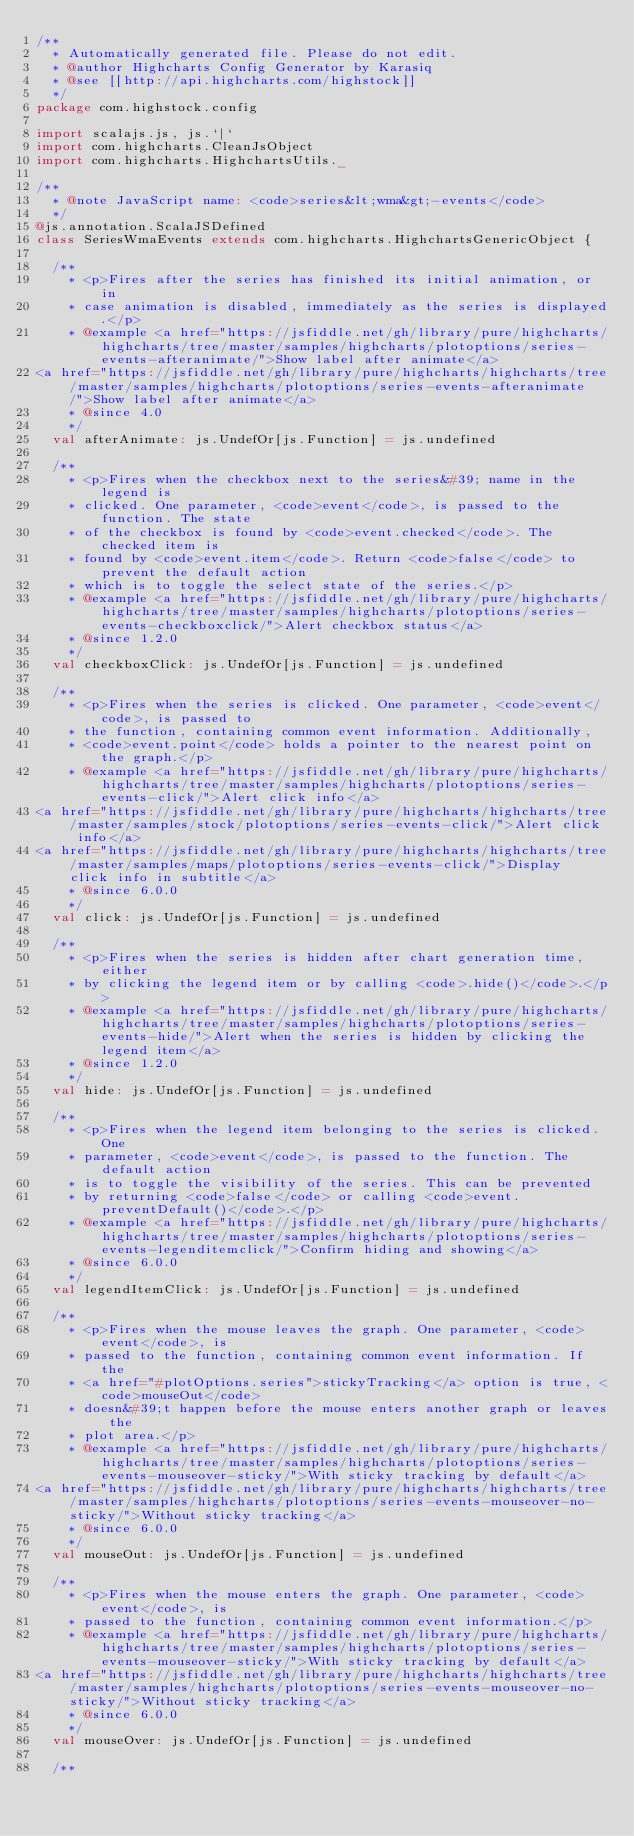<code> <loc_0><loc_0><loc_500><loc_500><_Scala_>/**
  * Automatically generated file. Please do not edit.
  * @author Highcharts Config Generator by Karasiq
  * @see [[http://api.highcharts.com/highstock]]
  */
package com.highstock.config

import scalajs.js, js.`|`
import com.highcharts.CleanJsObject
import com.highcharts.HighchartsUtils._

/**
  * @note JavaScript name: <code>series&lt;wma&gt;-events</code>
  */
@js.annotation.ScalaJSDefined
class SeriesWmaEvents extends com.highcharts.HighchartsGenericObject {

  /**
    * <p>Fires after the series has finished its initial animation, or in
    * case animation is disabled, immediately as the series is displayed.</p>
    * @example <a href="https://jsfiddle.net/gh/library/pure/highcharts/highcharts/tree/master/samples/highcharts/plotoptions/series-events-afteranimate/">Show label after animate</a>
<a href="https://jsfiddle.net/gh/library/pure/highcharts/highcharts/tree/master/samples/highcharts/plotoptions/series-events-afteranimate/">Show label after animate</a>
    * @since 4.0
    */
  val afterAnimate: js.UndefOr[js.Function] = js.undefined

  /**
    * <p>Fires when the checkbox next to the series&#39; name in the legend is
    * clicked. One parameter, <code>event</code>, is passed to the function. The state
    * of the checkbox is found by <code>event.checked</code>. The checked item is
    * found by <code>event.item</code>. Return <code>false</code> to prevent the default action
    * which is to toggle the select state of the series.</p>
    * @example <a href="https://jsfiddle.net/gh/library/pure/highcharts/highcharts/tree/master/samples/highcharts/plotoptions/series-events-checkboxclick/">Alert checkbox status</a>
    * @since 1.2.0
    */
  val checkboxClick: js.UndefOr[js.Function] = js.undefined

  /**
    * <p>Fires when the series is clicked. One parameter, <code>event</code>, is passed to
    * the function, containing common event information. Additionally,
    * <code>event.point</code> holds a pointer to the nearest point on the graph.</p>
    * @example <a href="https://jsfiddle.net/gh/library/pure/highcharts/highcharts/tree/master/samples/highcharts/plotoptions/series-events-click/">Alert click info</a>
<a href="https://jsfiddle.net/gh/library/pure/highcharts/highcharts/tree/master/samples/stock/plotoptions/series-events-click/">Alert click info</a>
<a href="https://jsfiddle.net/gh/library/pure/highcharts/highcharts/tree/master/samples/maps/plotoptions/series-events-click/">Display click info in subtitle</a>
    * @since 6.0.0
    */
  val click: js.UndefOr[js.Function] = js.undefined

  /**
    * <p>Fires when the series is hidden after chart generation time, either
    * by clicking the legend item or by calling <code>.hide()</code>.</p>
    * @example <a href="https://jsfiddle.net/gh/library/pure/highcharts/highcharts/tree/master/samples/highcharts/plotoptions/series-events-hide/">Alert when the series is hidden by clicking the legend item</a>
    * @since 1.2.0
    */
  val hide: js.UndefOr[js.Function] = js.undefined

  /**
    * <p>Fires when the legend item belonging to the series is clicked. One
    * parameter, <code>event</code>, is passed to the function. The default action
    * is to toggle the visibility of the series. This can be prevented
    * by returning <code>false</code> or calling <code>event.preventDefault()</code>.</p>
    * @example <a href="https://jsfiddle.net/gh/library/pure/highcharts/highcharts/tree/master/samples/highcharts/plotoptions/series-events-legenditemclick/">Confirm hiding and showing</a>
    * @since 6.0.0
    */
  val legendItemClick: js.UndefOr[js.Function] = js.undefined

  /**
    * <p>Fires when the mouse leaves the graph. One parameter, <code>event</code>, is
    * passed to the function, containing common event information. If the
    * <a href="#plotOptions.series">stickyTracking</a> option is true, <code>mouseOut</code>
    * doesn&#39;t happen before the mouse enters another graph or leaves the
    * plot area.</p>
    * @example <a href="https://jsfiddle.net/gh/library/pure/highcharts/highcharts/tree/master/samples/highcharts/plotoptions/series-events-mouseover-sticky/">With sticky tracking by default</a>
<a href="https://jsfiddle.net/gh/library/pure/highcharts/highcharts/tree/master/samples/highcharts/plotoptions/series-events-mouseover-no-sticky/">Without sticky tracking</a>
    * @since 6.0.0
    */
  val mouseOut: js.UndefOr[js.Function] = js.undefined

  /**
    * <p>Fires when the mouse enters the graph. One parameter, <code>event</code>, is
    * passed to the function, containing common event information.</p>
    * @example <a href="https://jsfiddle.net/gh/library/pure/highcharts/highcharts/tree/master/samples/highcharts/plotoptions/series-events-mouseover-sticky/">With sticky tracking by default</a>
<a href="https://jsfiddle.net/gh/library/pure/highcharts/highcharts/tree/master/samples/highcharts/plotoptions/series-events-mouseover-no-sticky/">Without sticky tracking</a>
    * @since 6.0.0
    */
  val mouseOver: js.UndefOr[js.Function] = js.undefined

  /**</code> 